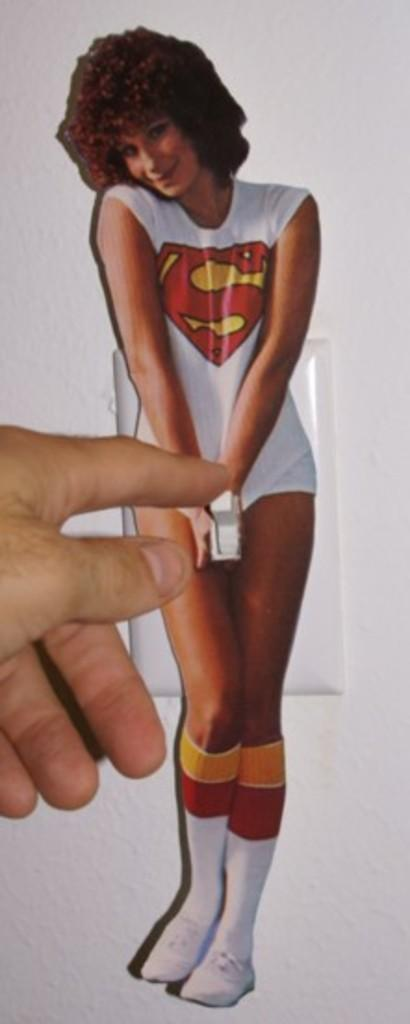What part of a person is visible in the image? There is a person's hand in the image. What is depicted on the switchboard in the image? There is a sticker of a woman on a switchboard in the image. What can be seen behind the hand and switchboard in the image? There is a wall in the background of the image. What type of prose can be heard being read aloud in the image? There is no indication of any prose being read aloud in the image, as it only features a person's hand and a sticker on a switchboard. 